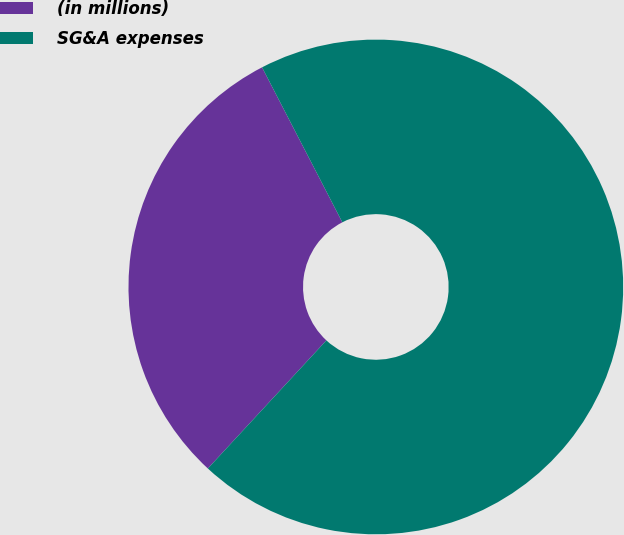Convert chart. <chart><loc_0><loc_0><loc_500><loc_500><pie_chart><fcel>(in millions)<fcel>SG&A expenses<nl><fcel>30.51%<fcel>69.49%<nl></chart> 